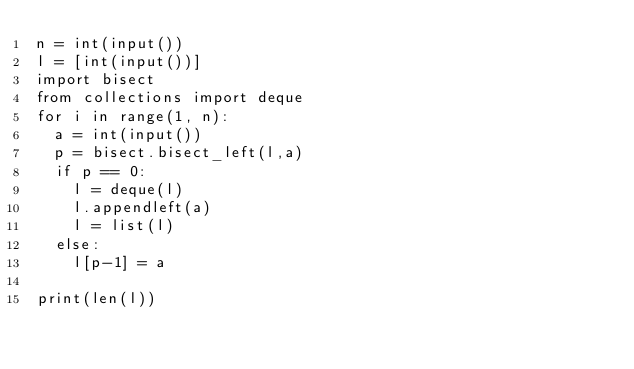<code> <loc_0><loc_0><loc_500><loc_500><_Python_>n = int(input())
l = [int(input())]
import bisect
from collections import deque
for i in range(1, n):
  a = int(input())
  p = bisect.bisect_left(l,a)
  if p == 0:
    l = deque(l)
    l.appendleft(a)
    l = list(l)
  else:
    l[p-1] = a

print(len(l))</code> 